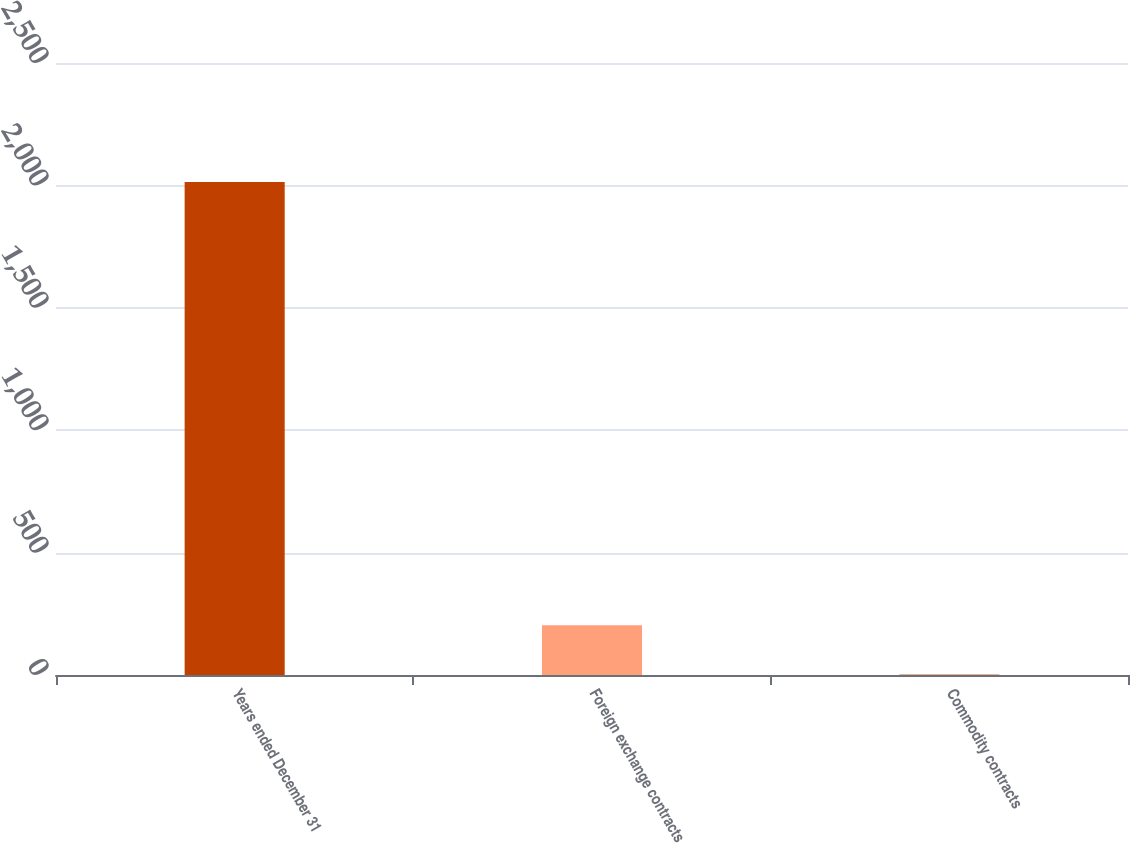Convert chart. <chart><loc_0><loc_0><loc_500><loc_500><bar_chart><fcel>Years ended December 31<fcel>Foreign exchange contracts<fcel>Commodity contracts<nl><fcel>2014<fcel>203.2<fcel>2<nl></chart> 